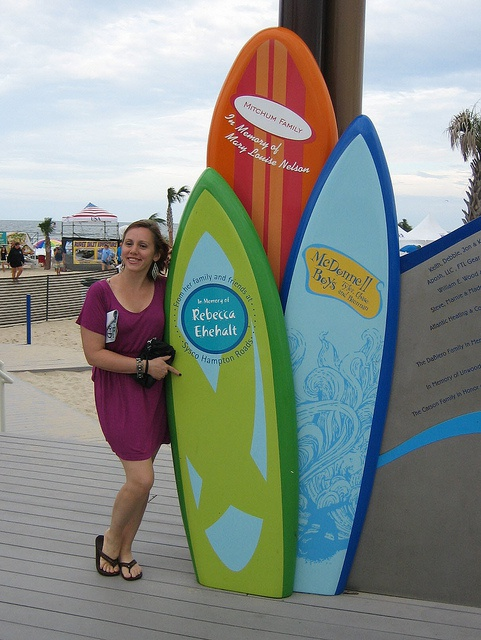Describe the objects in this image and their specific colors. I can see surfboard in lavender, lightblue, teal, navy, and gray tones, surfboard in white, olive, darkgreen, and lightblue tones, surfboard in white, brown, darkgray, and maroon tones, people in white, purple, black, and gray tones, and handbag in lavender, black, gray, and darkgreen tones in this image. 